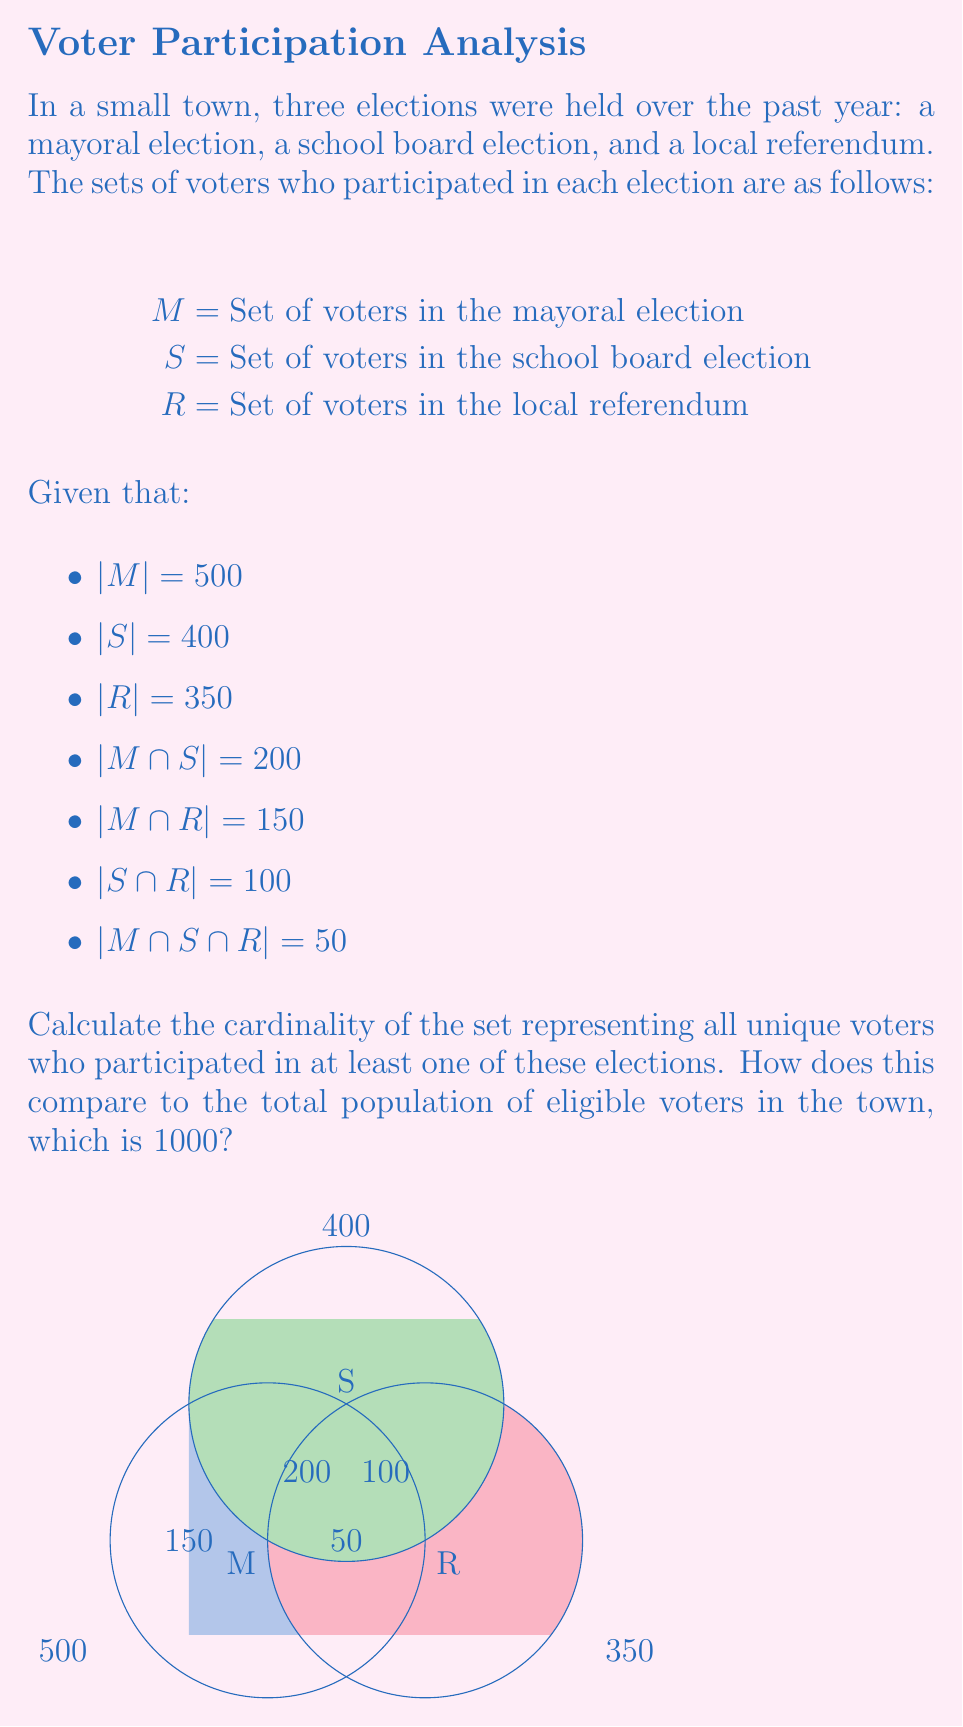What is the answer to this math problem? To solve this problem, we'll use the Inclusion-Exclusion Principle for three sets. The principle states that for sets A, B, and C:

$$|A \cup B \cup C| = |A| + |B| + |C| - |A \cap B| - |A \cap C| - |B \cap C| + |A \cap B \cap C|$$

In our case:
1. Let's substitute the given values into the formula:
   $$|M \cup S \cup R| = 500 + 400 + 350 - 200 - 150 - 100 + 50$$

2. Now, let's calculate:
   $$|M \cup S \cup R| = 1250 - 450 + 50 = 850$$

3. Therefore, the total number of unique voters who participated in at least one election is 850.

4. To compare this to the total population of eligible voters:
   - Total eligible voters: 1000
   - Voters who participated in at least one election: 850
   - Percentage of participation: $(850 / 1000) * 100 = 85\%$

5. The number of eligible voters who didn't participate in any election:
   $$1000 - 850 = 150$$

This analysis shows a high level of civic engagement in the town, with 85% of eligible voters participating in at least one election. However, there's still room for improvement to engage the remaining 15% of the population.
Answer: 850 unique voters; 85% participation rate 